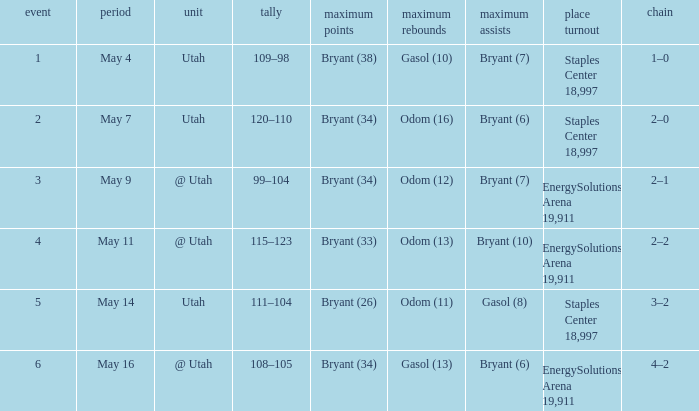What is the High rebounds with a Series with 4–2? Gasol (13). 